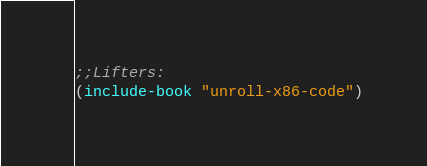Convert code to text. <code><loc_0><loc_0><loc_500><loc_500><_Lisp_>
;;Lifters:
(include-book "unroll-x86-code")
</code> 